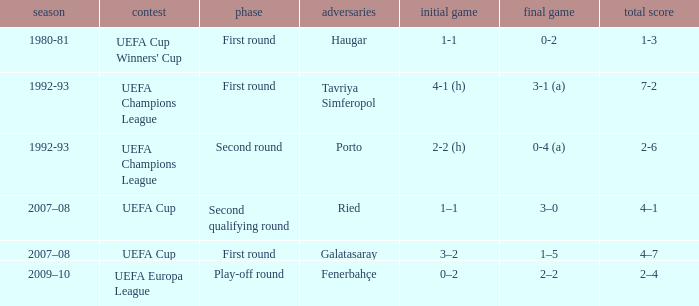 what's the competition where aggregate is 4–7 UEFA Cup. 